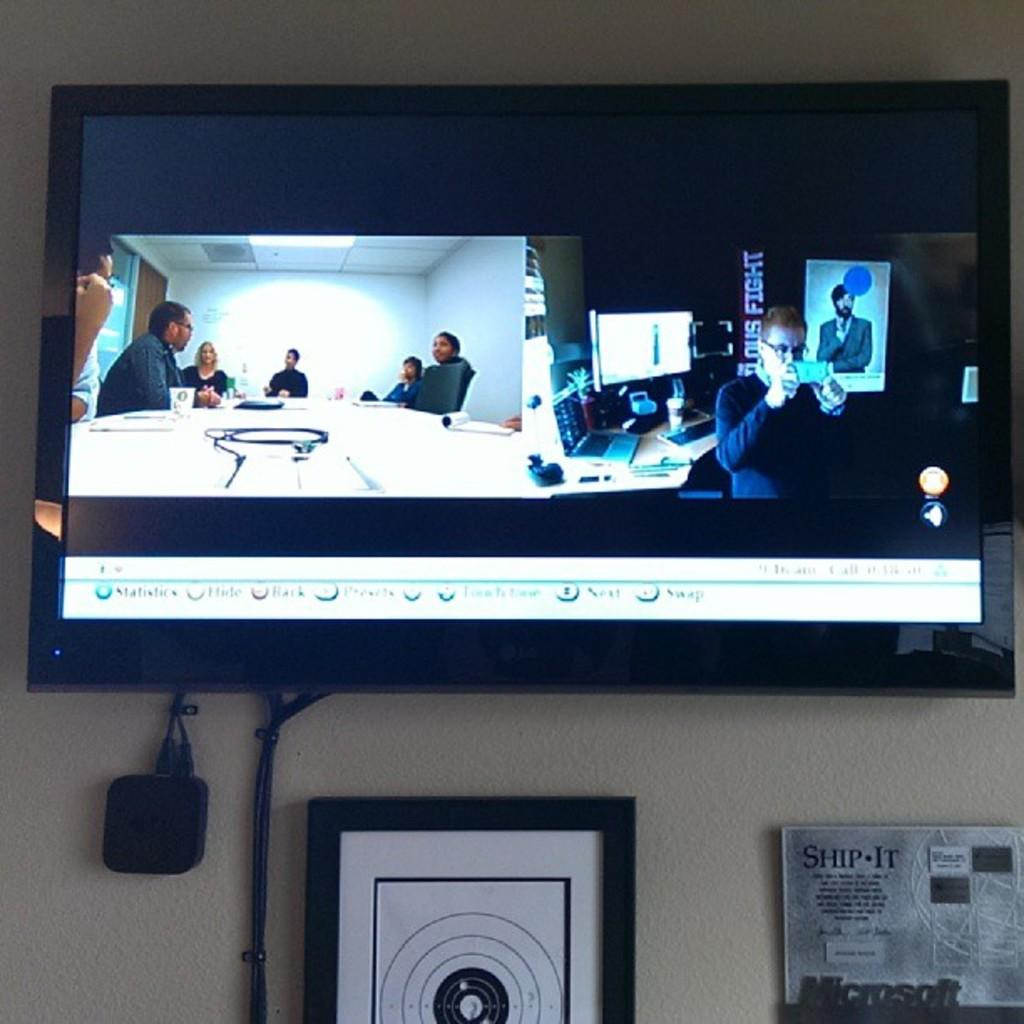Provide a one-sentence caption for the provided image. A television is on the wall and there is a sign under it that says, "SHIP-IT". 